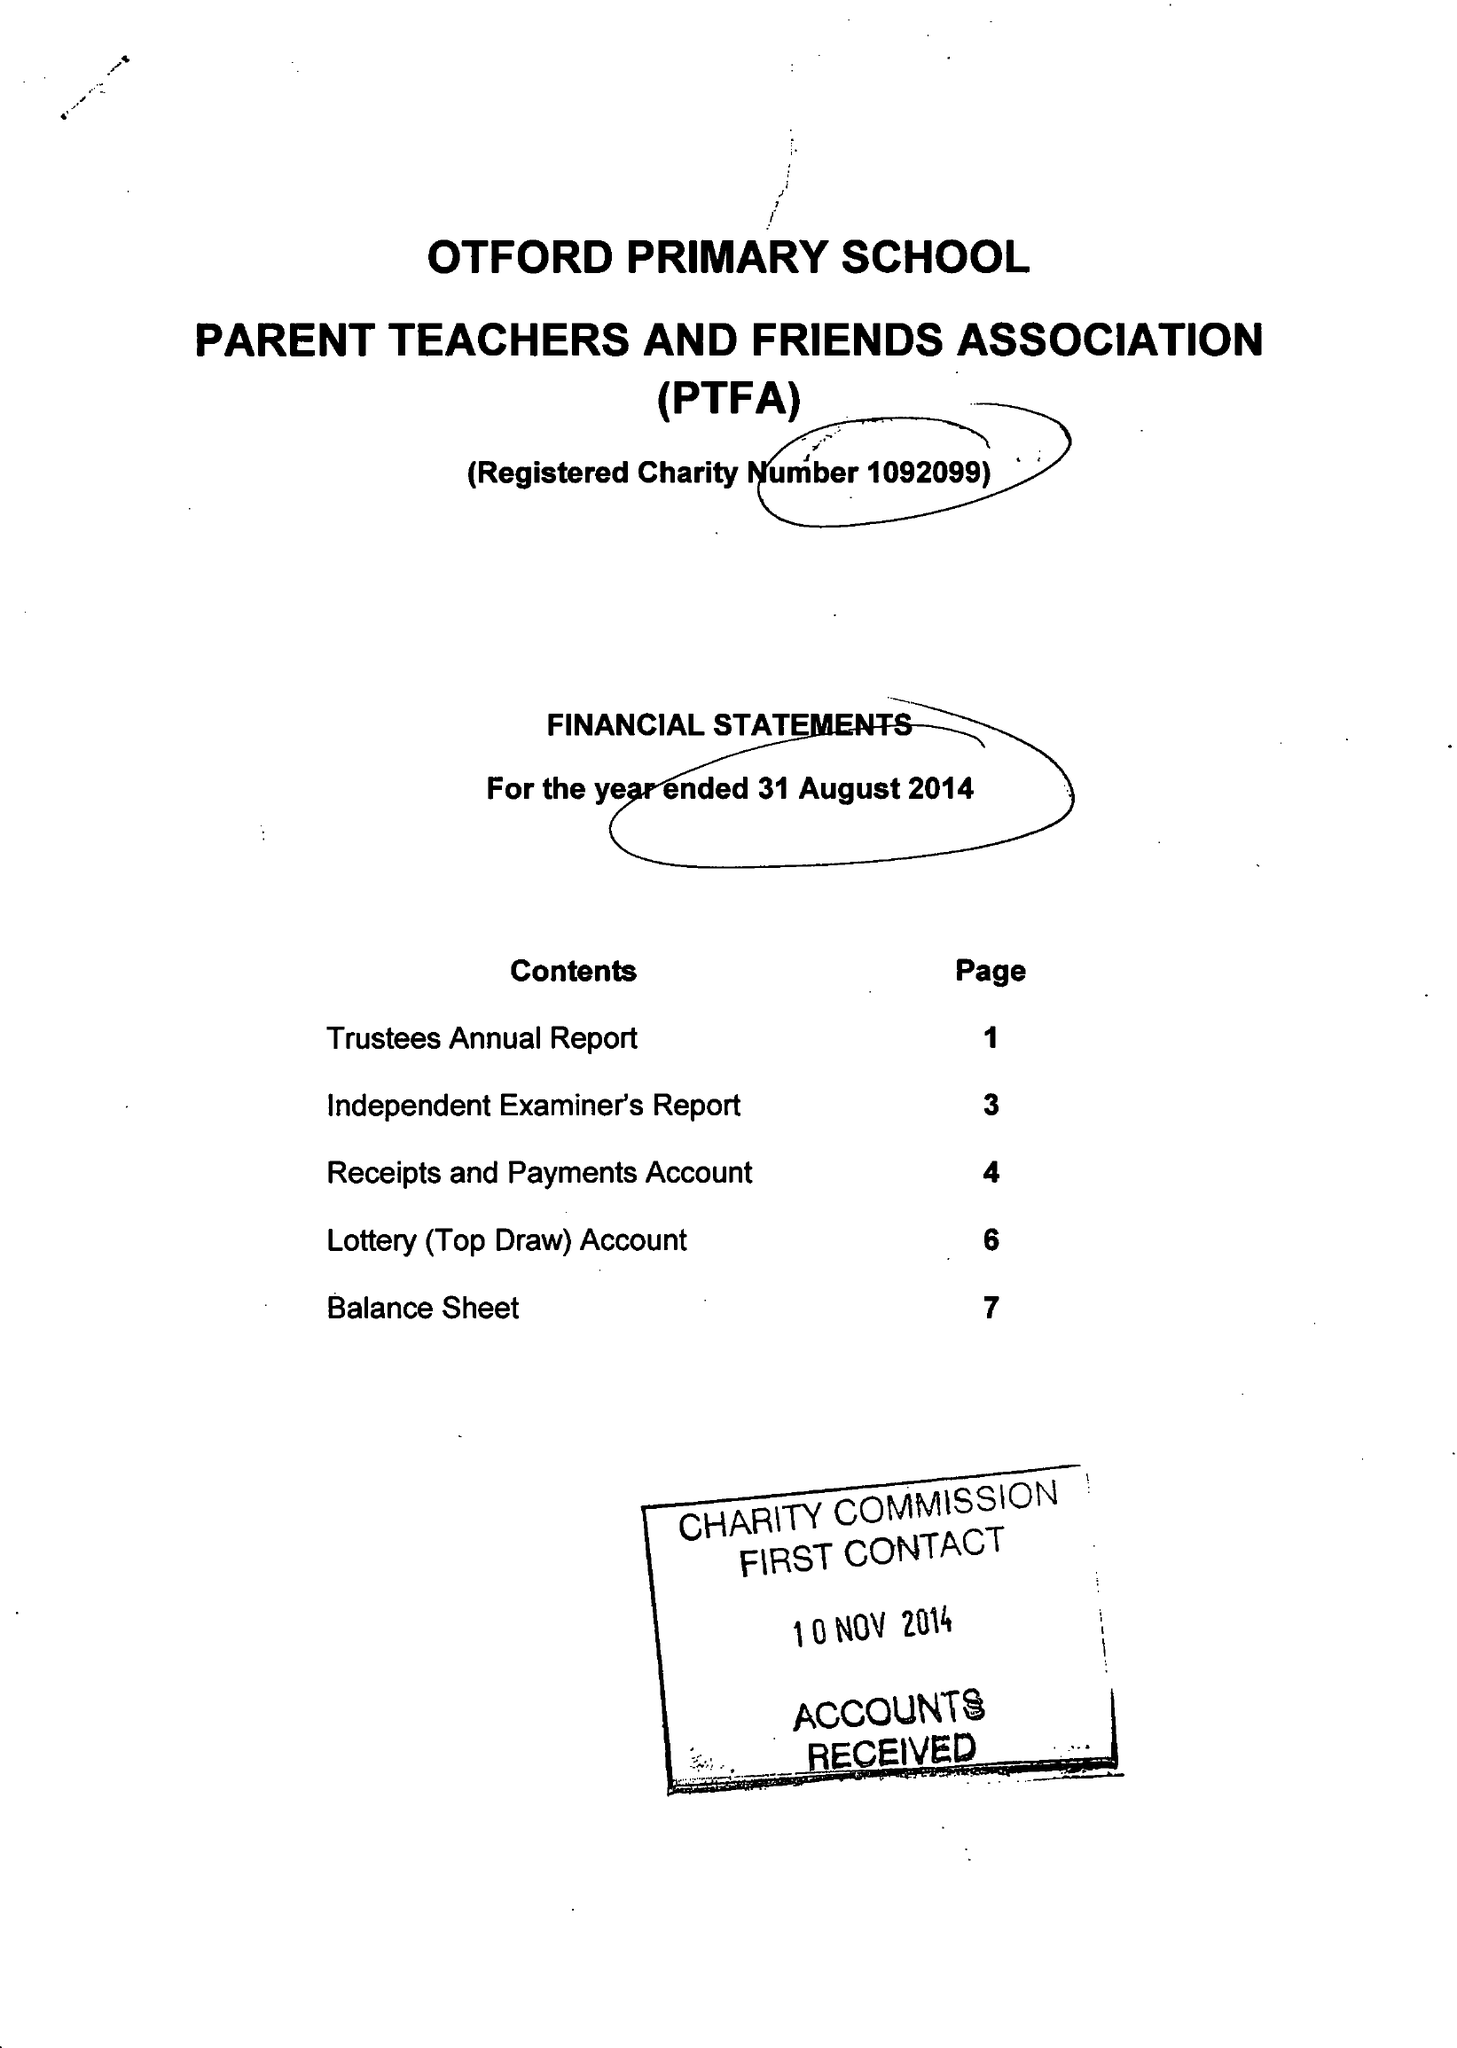What is the value for the address__postcode?
Answer the question using a single word or phrase. TN14 5PG 